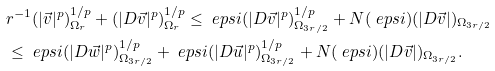Convert formula to latex. <formula><loc_0><loc_0><loc_500><loc_500>& r ^ { - 1 } ( | \vec { v } | ^ { p } ) ^ { 1 / p } _ { \Omega _ { r } } + ( | D \vec { v } | ^ { p } ) ^ { 1 / p } _ { \Omega _ { r } } \leq \ e p s i ( | D \vec { v } | ^ { p } ) ^ { 1 / p } _ { \Omega _ { 3 r / 2 } } + N ( \ e p s i ) ( | D \vec { v } | ) _ { \Omega _ { 3 r / 2 } } \\ & \leq \ e p s i ( | D \vec { w } | ^ { p } ) ^ { 1 / p } _ { \Omega _ { 3 r / 2 } } + \ e p s i ( | D \vec { u } | ^ { p } ) ^ { 1 / p } _ { \Omega _ { 3 r / 2 } } + N ( \ e p s i ) ( | D \vec { v } | ) _ { \Omega _ { 3 r / 2 } } .</formula> 